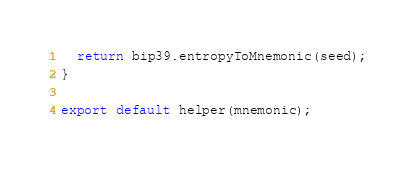Convert code to text. <code><loc_0><loc_0><loc_500><loc_500><_JavaScript_>
  return bip39.entropyToMnemonic(seed);
}

export default helper(mnemonic);
</code> 